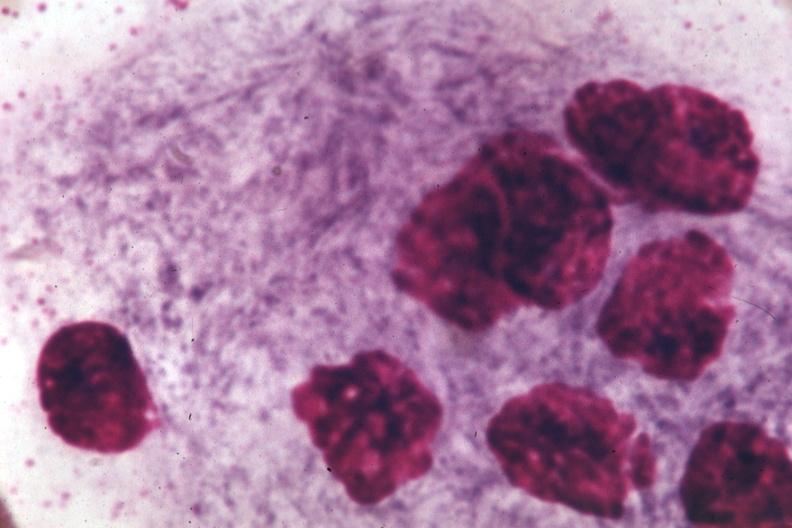does this image show oil immersion wrights typical cell?
Answer the question using a single word or phrase. Yes 